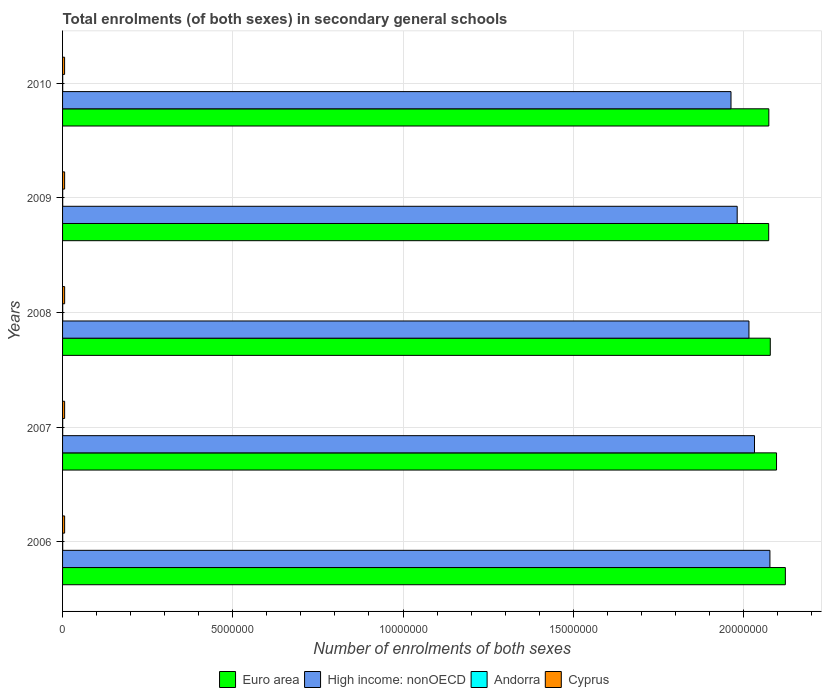How many different coloured bars are there?
Offer a terse response. 4. How many bars are there on the 3rd tick from the top?
Your answer should be compact. 4. What is the label of the 3rd group of bars from the top?
Keep it short and to the point. 2008. In how many cases, is the number of bars for a given year not equal to the number of legend labels?
Give a very brief answer. 0. What is the number of enrolments in secondary schools in Andorra in 2008?
Your answer should be compact. 3589. Across all years, what is the maximum number of enrolments in secondary schools in Andorra?
Your answer should be compact. 3692. Across all years, what is the minimum number of enrolments in secondary schools in Andorra?
Give a very brief answer. 3574. In which year was the number of enrolments in secondary schools in Euro area maximum?
Make the answer very short. 2006. What is the total number of enrolments in secondary schools in Euro area in the graph?
Ensure brevity in your answer.  1.04e+08. What is the difference between the number of enrolments in secondary schools in Euro area in 2006 and that in 2010?
Give a very brief answer. 4.85e+05. What is the difference between the number of enrolments in secondary schools in Andorra in 2008 and the number of enrolments in secondary schools in High income: nonOECD in 2007?
Keep it short and to the point. -2.03e+07. What is the average number of enrolments in secondary schools in Andorra per year?
Make the answer very short. 3610.8. In the year 2008, what is the difference between the number of enrolments in secondary schools in Euro area and number of enrolments in secondary schools in Cyprus?
Give a very brief answer. 2.07e+07. What is the ratio of the number of enrolments in secondary schools in Cyprus in 2006 to that in 2009?
Your answer should be compact. 1. Is the number of enrolments in secondary schools in Andorra in 2006 less than that in 2007?
Provide a short and direct response. No. What is the difference between the highest and the lowest number of enrolments in secondary schools in Andorra?
Offer a very short reply. 118. In how many years, is the number of enrolments in secondary schools in Andorra greater than the average number of enrolments in secondary schools in Andorra taken over all years?
Provide a succinct answer. 1. What does the 4th bar from the bottom in 2010 represents?
Your answer should be very brief. Cyprus. How many bars are there?
Give a very brief answer. 20. Are all the bars in the graph horizontal?
Provide a succinct answer. Yes. Are the values on the major ticks of X-axis written in scientific E-notation?
Give a very brief answer. No. Where does the legend appear in the graph?
Keep it short and to the point. Bottom center. What is the title of the graph?
Keep it short and to the point. Total enrolments (of both sexes) in secondary general schools. What is the label or title of the X-axis?
Keep it short and to the point. Number of enrolments of both sexes. What is the Number of enrolments of both sexes of Euro area in 2006?
Your response must be concise. 2.12e+07. What is the Number of enrolments of both sexes in High income: nonOECD in 2006?
Ensure brevity in your answer.  2.08e+07. What is the Number of enrolments of both sexes in Andorra in 2006?
Offer a terse response. 3597. What is the Number of enrolments of both sexes of Cyprus in 2006?
Provide a short and direct response. 6.04e+04. What is the Number of enrolments of both sexes of Euro area in 2007?
Keep it short and to the point. 2.10e+07. What is the Number of enrolments of both sexes of High income: nonOECD in 2007?
Keep it short and to the point. 2.03e+07. What is the Number of enrolments of both sexes in Andorra in 2007?
Your response must be concise. 3574. What is the Number of enrolments of both sexes of Cyprus in 2007?
Your answer should be compact. 6.06e+04. What is the Number of enrolments of both sexes of Euro area in 2008?
Provide a short and direct response. 2.08e+07. What is the Number of enrolments of both sexes in High income: nonOECD in 2008?
Your response must be concise. 2.02e+07. What is the Number of enrolments of both sexes of Andorra in 2008?
Provide a short and direct response. 3589. What is the Number of enrolments of both sexes of Cyprus in 2008?
Offer a terse response. 6.09e+04. What is the Number of enrolments of both sexes in Euro area in 2009?
Make the answer very short. 2.07e+07. What is the Number of enrolments of both sexes in High income: nonOECD in 2009?
Offer a very short reply. 1.98e+07. What is the Number of enrolments of both sexes in Andorra in 2009?
Keep it short and to the point. 3602. What is the Number of enrolments of both sexes of Cyprus in 2009?
Your answer should be compact. 6.05e+04. What is the Number of enrolments of both sexes of Euro area in 2010?
Offer a very short reply. 2.07e+07. What is the Number of enrolments of both sexes in High income: nonOECD in 2010?
Ensure brevity in your answer.  1.96e+07. What is the Number of enrolments of both sexes in Andorra in 2010?
Provide a succinct answer. 3692. What is the Number of enrolments of both sexes in Cyprus in 2010?
Offer a very short reply. 5.94e+04. Across all years, what is the maximum Number of enrolments of both sexes of Euro area?
Provide a succinct answer. 2.12e+07. Across all years, what is the maximum Number of enrolments of both sexes of High income: nonOECD?
Give a very brief answer. 2.08e+07. Across all years, what is the maximum Number of enrolments of both sexes of Andorra?
Offer a very short reply. 3692. Across all years, what is the maximum Number of enrolments of both sexes in Cyprus?
Offer a terse response. 6.09e+04. Across all years, what is the minimum Number of enrolments of both sexes of Euro area?
Ensure brevity in your answer.  2.07e+07. Across all years, what is the minimum Number of enrolments of both sexes in High income: nonOECD?
Make the answer very short. 1.96e+07. Across all years, what is the minimum Number of enrolments of both sexes in Andorra?
Your answer should be compact. 3574. Across all years, what is the minimum Number of enrolments of both sexes of Cyprus?
Provide a short and direct response. 5.94e+04. What is the total Number of enrolments of both sexes in Euro area in the graph?
Your answer should be compact. 1.04e+08. What is the total Number of enrolments of both sexes of High income: nonOECD in the graph?
Provide a short and direct response. 1.01e+08. What is the total Number of enrolments of both sexes in Andorra in the graph?
Give a very brief answer. 1.81e+04. What is the total Number of enrolments of both sexes in Cyprus in the graph?
Ensure brevity in your answer.  3.02e+05. What is the difference between the Number of enrolments of both sexes of Euro area in 2006 and that in 2007?
Give a very brief answer. 2.59e+05. What is the difference between the Number of enrolments of both sexes in High income: nonOECD in 2006 and that in 2007?
Your answer should be compact. 4.53e+05. What is the difference between the Number of enrolments of both sexes in Andorra in 2006 and that in 2007?
Give a very brief answer. 23. What is the difference between the Number of enrolments of both sexes of Cyprus in 2006 and that in 2007?
Your answer should be compact. -239. What is the difference between the Number of enrolments of both sexes in Euro area in 2006 and that in 2008?
Offer a very short reply. 4.43e+05. What is the difference between the Number of enrolments of both sexes of High income: nonOECD in 2006 and that in 2008?
Your response must be concise. 6.16e+05. What is the difference between the Number of enrolments of both sexes in Andorra in 2006 and that in 2008?
Offer a terse response. 8. What is the difference between the Number of enrolments of both sexes in Cyprus in 2006 and that in 2008?
Your answer should be compact. -505. What is the difference between the Number of enrolments of both sexes in Euro area in 2006 and that in 2009?
Ensure brevity in your answer.  4.89e+05. What is the difference between the Number of enrolments of both sexes of High income: nonOECD in 2006 and that in 2009?
Offer a terse response. 9.61e+05. What is the difference between the Number of enrolments of both sexes of Andorra in 2006 and that in 2009?
Your response must be concise. -5. What is the difference between the Number of enrolments of both sexes in Cyprus in 2006 and that in 2009?
Keep it short and to the point. -41. What is the difference between the Number of enrolments of both sexes of Euro area in 2006 and that in 2010?
Offer a very short reply. 4.85e+05. What is the difference between the Number of enrolments of both sexes in High income: nonOECD in 2006 and that in 2010?
Give a very brief answer. 1.14e+06. What is the difference between the Number of enrolments of both sexes in Andorra in 2006 and that in 2010?
Your response must be concise. -95. What is the difference between the Number of enrolments of both sexes of Cyprus in 2006 and that in 2010?
Provide a short and direct response. 984. What is the difference between the Number of enrolments of both sexes in Euro area in 2007 and that in 2008?
Make the answer very short. 1.84e+05. What is the difference between the Number of enrolments of both sexes of High income: nonOECD in 2007 and that in 2008?
Keep it short and to the point. 1.63e+05. What is the difference between the Number of enrolments of both sexes in Cyprus in 2007 and that in 2008?
Keep it short and to the point. -266. What is the difference between the Number of enrolments of both sexes of Euro area in 2007 and that in 2009?
Offer a terse response. 2.30e+05. What is the difference between the Number of enrolments of both sexes in High income: nonOECD in 2007 and that in 2009?
Make the answer very short. 5.08e+05. What is the difference between the Number of enrolments of both sexes in Cyprus in 2007 and that in 2009?
Provide a succinct answer. 198. What is the difference between the Number of enrolments of both sexes in Euro area in 2007 and that in 2010?
Your response must be concise. 2.26e+05. What is the difference between the Number of enrolments of both sexes in High income: nonOECD in 2007 and that in 2010?
Offer a terse response. 6.90e+05. What is the difference between the Number of enrolments of both sexes in Andorra in 2007 and that in 2010?
Your response must be concise. -118. What is the difference between the Number of enrolments of both sexes of Cyprus in 2007 and that in 2010?
Your answer should be compact. 1223. What is the difference between the Number of enrolments of both sexes of Euro area in 2008 and that in 2009?
Offer a very short reply. 4.64e+04. What is the difference between the Number of enrolments of both sexes of High income: nonOECD in 2008 and that in 2009?
Your answer should be compact. 3.46e+05. What is the difference between the Number of enrolments of both sexes of Cyprus in 2008 and that in 2009?
Your answer should be compact. 464. What is the difference between the Number of enrolments of both sexes in Euro area in 2008 and that in 2010?
Offer a terse response. 4.25e+04. What is the difference between the Number of enrolments of both sexes of High income: nonOECD in 2008 and that in 2010?
Your answer should be compact. 5.27e+05. What is the difference between the Number of enrolments of both sexes in Andorra in 2008 and that in 2010?
Offer a very short reply. -103. What is the difference between the Number of enrolments of both sexes in Cyprus in 2008 and that in 2010?
Give a very brief answer. 1489. What is the difference between the Number of enrolments of both sexes in Euro area in 2009 and that in 2010?
Offer a terse response. -3894. What is the difference between the Number of enrolments of both sexes of High income: nonOECD in 2009 and that in 2010?
Make the answer very short. 1.82e+05. What is the difference between the Number of enrolments of both sexes in Andorra in 2009 and that in 2010?
Make the answer very short. -90. What is the difference between the Number of enrolments of both sexes of Cyprus in 2009 and that in 2010?
Keep it short and to the point. 1025. What is the difference between the Number of enrolments of both sexes of Euro area in 2006 and the Number of enrolments of both sexes of High income: nonOECD in 2007?
Ensure brevity in your answer.  9.06e+05. What is the difference between the Number of enrolments of both sexes of Euro area in 2006 and the Number of enrolments of both sexes of Andorra in 2007?
Provide a succinct answer. 2.12e+07. What is the difference between the Number of enrolments of both sexes of Euro area in 2006 and the Number of enrolments of both sexes of Cyprus in 2007?
Give a very brief answer. 2.12e+07. What is the difference between the Number of enrolments of both sexes in High income: nonOECD in 2006 and the Number of enrolments of both sexes in Andorra in 2007?
Your answer should be compact. 2.08e+07. What is the difference between the Number of enrolments of both sexes of High income: nonOECD in 2006 and the Number of enrolments of both sexes of Cyprus in 2007?
Offer a terse response. 2.07e+07. What is the difference between the Number of enrolments of both sexes of Andorra in 2006 and the Number of enrolments of both sexes of Cyprus in 2007?
Your answer should be compact. -5.71e+04. What is the difference between the Number of enrolments of both sexes in Euro area in 2006 and the Number of enrolments of both sexes in High income: nonOECD in 2008?
Give a very brief answer. 1.07e+06. What is the difference between the Number of enrolments of both sexes of Euro area in 2006 and the Number of enrolments of both sexes of Andorra in 2008?
Keep it short and to the point. 2.12e+07. What is the difference between the Number of enrolments of both sexes of Euro area in 2006 and the Number of enrolments of both sexes of Cyprus in 2008?
Ensure brevity in your answer.  2.12e+07. What is the difference between the Number of enrolments of both sexes of High income: nonOECD in 2006 and the Number of enrolments of both sexes of Andorra in 2008?
Your answer should be compact. 2.08e+07. What is the difference between the Number of enrolments of both sexes in High income: nonOECD in 2006 and the Number of enrolments of both sexes in Cyprus in 2008?
Offer a very short reply. 2.07e+07. What is the difference between the Number of enrolments of both sexes of Andorra in 2006 and the Number of enrolments of both sexes of Cyprus in 2008?
Give a very brief answer. -5.73e+04. What is the difference between the Number of enrolments of both sexes of Euro area in 2006 and the Number of enrolments of both sexes of High income: nonOECD in 2009?
Offer a very short reply. 1.41e+06. What is the difference between the Number of enrolments of both sexes in Euro area in 2006 and the Number of enrolments of both sexes in Andorra in 2009?
Provide a succinct answer. 2.12e+07. What is the difference between the Number of enrolments of both sexes in Euro area in 2006 and the Number of enrolments of both sexes in Cyprus in 2009?
Make the answer very short. 2.12e+07. What is the difference between the Number of enrolments of both sexes of High income: nonOECD in 2006 and the Number of enrolments of both sexes of Andorra in 2009?
Make the answer very short. 2.08e+07. What is the difference between the Number of enrolments of both sexes of High income: nonOECD in 2006 and the Number of enrolments of both sexes of Cyprus in 2009?
Offer a very short reply. 2.07e+07. What is the difference between the Number of enrolments of both sexes of Andorra in 2006 and the Number of enrolments of both sexes of Cyprus in 2009?
Your answer should be very brief. -5.69e+04. What is the difference between the Number of enrolments of both sexes in Euro area in 2006 and the Number of enrolments of both sexes in High income: nonOECD in 2010?
Make the answer very short. 1.60e+06. What is the difference between the Number of enrolments of both sexes of Euro area in 2006 and the Number of enrolments of both sexes of Andorra in 2010?
Make the answer very short. 2.12e+07. What is the difference between the Number of enrolments of both sexes of Euro area in 2006 and the Number of enrolments of both sexes of Cyprus in 2010?
Give a very brief answer. 2.12e+07. What is the difference between the Number of enrolments of both sexes of High income: nonOECD in 2006 and the Number of enrolments of both sexes of Andorra in 2010?
Keep it short and to the point. 2.08e+07. What is the difference between the Number of enrolments of both sexes in High income: nonOECD in 2006 and the Number of enrolments of both sexes in Cyprus in 2010?
Offer a very short reply. 2.07e+07. What is the difference between the Number of enrolments of both sexes in Andorra in 2006 and the Number of enrolments of both sexes in Cyprus in 2010?
Offer a very short reply. -5.58e+04. What is the difference between the Number of enrolments of both sexes in Euro area in 2007 and the Number of enrolments of both sexes in High income: nonOECD in 2008?
Provide a succinct answer. 8.10e+05. What is the difference between the Number of enrolments of both sexes in Euro area in 2007 and the Number of enrolments of both sexes in Andorra in 2008?
Keep it short and to the point. 2.10e+07. What is the difference between the Number of enrolments of both sexes in Euro area in 2007 and the Number of enrolments of both sexes in Cyprus in 2008?
Provide a succinct answer. 2.09e+07. What is the difference between the Number of enrolments of both sexes of High income: nonOECD in 2007 and the Number of enrolments of both sexes of Andorra in 2008?
Give a very brief answer. 2.03e+07. What is the difference between the Number of enrolments of both sexes of High income: nonOECD in 2007 and the Number of enrolments of both sexes of Cyprus in 2008?
Provide a short and direct response. 2.03e+07. What is the difference between the Number of enrolments of both sexes of Andorra in 2007 and the Number of enrolments of both sexes of Cyprus in 2008?
Offer a terse response. -5.73e+04. What is the difference between the Number of enrolments of both sexes in Euro area in 2007 and the Number of enrolments of both sexes in High income: nonOECD in 2009?
Ensure brevity in your answer.  1.16e+06. What is the difference between the Number of enrolments of both sexes of Euro area in 2007 and the Number of enrolments of both sexes of Andorra in 2009?
Provide a short and direct response. 2.10e+07. What is the difference between the Number of enrolments of both sexes in Euro area in 2007 and the Number of enrolments of both sexes in Cyprus in 2009?
Provide a succinct answer. 2.09e+07. What is the difference between the Number of enrolments of both sexes of High income: nonOECD in 2007 and the Number of enrolments of both sexes of Andorra in 2009?
Your answer should be very brief. 2.03e+07. What is the difference between the Number of enrolments of both sexes of High income: nonOECD in 2007 and the Number of enrolments of both sexes of Cyprus in 2009?
Provide a succinct answer. 2.03e+07. What is the difference between the Number of enrolments of both sexes of Andorra in 2007 and the Number of enrolments of both sexes of Cyprus in 2009?
Provide a short and direct response. -5.69e+04. What is the difference between the Number of enrolments of both sexes of Euro area in 2007 and the Number of enrolments of both sexes of High income: nonOECD in 2010?
Your answer should be very brief. 1.34e+06. What is the difference between the Number of enrolments of both sexes of Euro area in 2007 and the Number of enrolments of both sexes of Andorra in 2010?
Your response must be concise. 2.10e+07. What is the difference between the Number of enrolments of both sexes of Euro area in 2007 and the Number of enrolments of both sexes of Cyprus in 2010?
Your answer should be very brief. 2.09e+07. What is the difference between the Number of enrolments of both sexes in High income: nonOECD in 2007 and the Number of enrolments of both sexes in Andorra in 2010?
Provide a short and direct response. 2.03e+07. What is the difference between the Number of enrolments of both sexes of High income: nonOECD in 2007 and the Number of enrolments of both sexes of Cyprus in 2010?
Give a very brief answer. 2.03e+07. What is the difference between the Number of enrolments of both sexes in Andorra in 2007 and the Number of enrolments of both sexes in Cyprus in 2010?
Your answer should be very brief. -5.59e+04. What is the difference between the Number of enrolments of both sexes of Euro area in 2008 and the Number of enrolments of both sexes of High income: nonOECD in 2009?
Provide a succinct answer. 9.72e+05. What is the difference between the Number of enrolments of both sexes in Euro area in 2008 and the Number of enrolments of both sexes in Andorra in 2009?
Give a very brief answer. 2.08e+07. What is the difference between the Number of enrolments of both sexes of Euro area in 2008 and the Number of enrolments of both sexes of Cyprus in 2009?
Give a very brief answer. 2.07e+07. What is the difference between the Number of enrolments of both sexes in High income: nonOECD in 2008 and the Number of enrolments of both sexes in Andorra in 2009?
Keep it short and to the point. 2.02e+07. What is the difference between the Number of enrolments of both sexes in High income: nonOECD in 2008 and the Number of enrolments of both sexes in Cyprus in 2009?
Provide a succinct answer. 2.01e+07. What is the difference between the Number of enrolments of both sexes of Andorra in 2008 and the Number of enrolments of both sexes of Cyprus in 2009?
Your answer should be very brief. -5.69e+04. What is the difference between the Number of enrolments of both sexes in Euro area in 2008 and the Number of enrolments of both sexes in High income: nonOECD in 2010?
Make the answer very short. 1.15e+06. What is the difference between the Number of enrolments of both sexes in Euro area in 2008 and the Number of enrolments of both sexes in Andorra in 2010?
Offer a terse response. 2.08e+07. What is the difference between the Number of enrolments of both sexes in Euro area in 2008 and the Number of enrolments of both sexes in Cyprus in 2010?
Offer a very short reply. 2.07e+07. What is the difference between the Number of enrolments of both sexes in High income: nonOECD in 2008 and the Number of enrolments of both sexes in Andorra in 2010?
Keep it short and to the point. 2.02e+07. What is the difference between the Number of enrolments of both sexes in High income: nonOECD in 2008 and the Number of enrolments of both sexes in Cyprus in 2010?
Offer a very short reply. 2.01e+07. What is the difference between the Number of enrolments of both sexes in Andorra in 2008 and the Number of enrolments of both sexes in Cyprus in 2010?
Provide a short and direct response. -5.58e+04. What is the difference between the Number of enrolments of both sexes of Euro area in 2009 and the Number of enrolments of both sexes of High income: nonOECD in 2010?
Offer a terse response. 1.11e+06. What is the difference between the Number of enrolments of both sexes in Euro area in 2009 and the Number of enrolments of both sexes in Andorra in 2010?
Offer a very short reply. 2.07e+07. What is the difference between the Number of enrolments of both sexes in Euro area in 2009 and the Number of enrolments of both sexes in Cyprus in 2010?
Offer a very short reply. 2.07e+07. What is the difference between the Number of enrolments of both sexes in High income: nonOECD in 2009 and the Number of enrolments of both sexes in Andorra in 2010?
Ensure brevity in your answer.  1.98e+07. What is the difference between the Number of enrolments of both sexes in High income: nonOECD in 2009 and the Number of enrolments of both sexes in Cyprus in 2010?
Your response must be concise. 1.98e+07. What is the difference between the Number of enrolments of both sexes in Andorra in 2009 and the Number of enrolments of both sexes in Cyprus in 2010?
Your answer should be very brief. -5.58e+04. What is the average Number of enrolments of both sexes in Euro area per year?
Make the answer very short. 2.09e+07. What is the average Number of enrolments of both sexes of High income: nonOECD per year?
Provide a succinct answer. 2.01e+07. What is the average Number of enrolments of both sexes in Andorra per year?
Your answer should be compact. 3610.8. What is the average Number of enrolments of both sexes in Cyprus per year?
Your response must be concise. 6.04e+04. In the year 2006, what is the difference between the Number of enrolments of both sexes in Euro area and Number of enrolments of both sexes in High income: nonOECD?
Offer a very short reply. 4.53e+05. In the year 2006, what is the difference between the Number of enrolments of both sexes in Euro area and Number of enrolments of both sexes in Andorra?
Provide a short and direct response. 2.12e+07. In the year 2006, what is the difference between the Number of enrolments of both sexes in Euro area and Number of enrolments of both sexes in Cyprus?
Your answer should be very brief. 2.12e+07. In the year 2006, what is the difference between the Number of enrolments of both sexes in High income: nonOECD and Number of enrolments of both sexes in Andorra?
Provide a short and direct response. 2.08e+07. In the year 2006, what is the difference between the Number of enrolments of both sexes of High income: nonOECD and Number of enrolments of both sexes of Cyprus?
Provide a succinct answer. 2.07e+07. In the year 2006, what is the difference between the Number of enrolments of both sexes in Andorra and Number of enrolments of both sexes in Cyprus?
Your answer should be compact. -5.68e+04. In the year 2007, what is the difference between the Number of enrolments of both sexes in Euro area and Number of enrolments of both sexes in High income: nonOECD?
Your answer should be compact. 6.47e+05. In the year 2007, what is the difference between the Number of enrolments of both sexes in Euro area and Number of enrolments of both sexes in Andorra?
Make the answer very short. 2.10e+07. In the year 2007, what is the difference between the Number of enrolments of both sexes in Euro area and Number of enrolments of both sexes in Cyprus?
Make the answer very short. 2.09e+07. In the year 2007, what is the difference between the Number of enrolments of both sexes of High income: nonOECD and Number of enrolments of both sexes of Andorra?
Give a very brief answer. 2.03e+07. In the year 2007, what is the difference between the Number of enrolments of both sexes in High income: nonOECD and Number of enrolments of both sexes in Cyprus?
Keep it short and to the point. 2.03e+07. In the year 2007, what is the difference between the Number of enrolments of both sexes in Andorra and Number of enrolments of both sexes in Cyprus?
Your response must be concise. -5.71e+04. In the year 2008, what is the difference between the Number of enrolments of both sexes in Euro area and Number of enrolments of both sexes in High income: nonOECD?
Your answer should be very brief. 6.26e+05. In the year 2008, what is the difference between the Number of enrolments of both sexes of Euro area and Number of enrolments of both sexes of Andorra?
Your answer should be very brief. 2.08e+07. In the year 2008, what is the difference between the Number of enrolments of both sexes of Euro area and Number of enrolments of both sexes of Cyprus?
Keep it short and to the point. 2.07e+07. In the year 2008, what is the difference between the Number of enrolments of both sexes in High income: nonOECD and Number of enrolments of both sexes in Andorra?
Offer a very short reply. 2.02e+07. In the year 2008, what is the difference between the Number of enrolments of both sexes of High income: nonOECD and Number of enrolments of both sexes of Cyprus?
Offer a very short reply. 2.01e+07. In the year 2008, what is the difference between the Number of enrolments of both sexes in Andorra and Number of enrolments of both sexes in Cyprus?
Give a very brief answer. -5.73e+04. In the year 2009, what is the difference between the Number of enrolments of both sexes of Euro area and Number of enrolments of both sexes of High income: nonOECD?
Offer a very short reply. 9.25e+05. In the year 2009, what is the difference between the Number of enrolments of both sexes of Euro area and Number of enrolments of both sexes of Andorra?
Make the answer very short. 2.07e+07. In the year 2009, what is the difference between the Number of enrolments of both sexes in Euro area and Number of enrolments of both sexes in Cyprus?
Provide a short and direct response. 2.07e+07. In the year 2009, what is the difference between the Number of enrolments of both sexes of High income: nonOECD and Number of enrolments of both sexes of Andorra?
Give a very brief answer. 1.98e+07. In the year 2009, what is the difference between the Number of enrolments of both sexes of High income: nonOECD and Number of enrolments of both sexes of Cyprus?
Give a very brief answer. 1.98e+07. In the year 2009, what is the difference between the Number of enrolments of both sexes in Andorra and Number of enrolments of both sexes in Cyprus?
Offer a terse response. -5.68e+04. In the year 2010, what is the difference between the Number of enrolments of both sexes of Euro area and Number of enrolments of both sexes of High income: nonOECD?
Your answer should be compact. 1.11e+06. In the year 2010, what is the difference between the Number of enrolments of both sexes of Euro area and Number of enrolments of both sexes of Andorra?
Keep it short and to the point. 2.07e+07. In the year 2010, what is the difference between the Number of enrolments of both sexes of Euro area and Number of enrolments of both sexes of Cyprus?
Offer a very short reply. 2.07e+07. In the year 2010, what is the difference between the Number of enrolments of both sexes in High income: nonOECD and Number of enrolments of both sexes in Andorra?
Offer a very short reply. 1.96e+07. In the year 2010, what is the difference between the Number of enrolments of both sexes in High income: nonOECD and Number of enrolments of both sexes in Cyprus?
Your answer should be very brief. 1.96e+07. In the year 2010, what is the difference between the Number of enrolments of both sexes of Andorra and Number of enrolments of both sexes of Cyprus?
Offer a terse response. -5.57e+04. What is the ratio of the Number of enrolments of both sexes in Euro area in 2006 to that in 2007?
Provide a succinct answer. 1.01. What is the ratio of the Number of enrolments of both sexes of High income: nonOECD in 2006 to that in 2007?
Provide a short and direct response. 1.02. What is the ratio of the Number of enrolments of both sexes in Andorra in 2006 to that in 2007?
Ensure brevity in your answer.  1.01. What is the ratio of the Number of enrolments of both sexes in Cyprus in 2006 to that in 2007?
Give a very brief answer. 1. What is the ratio of the Number of enrolments of both sexes in Euro area in 2006 to that in 2008?
Ensure brevity in your answer.  1.02. What is the ratio of the Number of enrolments of both sexes in High income: nonOECD in 2006 to that in 2008?
Provide a short and direct response. 1.03. What is the ratio of the Number of enrolments of both sexes in Andorra in 2006 to that in 2008?
Provide a short and direct response. 1. What is the ratio of the Number of enrolments of both sexes in Euro area in 2006 to that in 2009?
Ensure brevity in your answer.  1.02. What is the ratio of the Number of enrolments of both sexes in High income: nonOECD in 2006 to that in 2009?
Offer a very short reply. 1.05. What is the ratio of the Number of enrolments of both sexes in Andorra in 2006 to that in 2009?
Keep it short and to the point. 1. What is the ratio of the Number of enrolments of both sexes of Euro area in 2006 to that in 2010?
Make the answer very short. 1.02. What is the ratio of the Number of enrolments of both sexes of High income: nonOECD in 2006 to that in 2010?
Make the answer very short. 1.06. What is the ratio of the Number of enrolments of both sexes of Andorra in 2006 to that in 2010?
Make the answer very short. 0.97. What is the ratio of the Number of enrolments of both sexes in Cyprus in 2006 to that in 2010?
Ensure brevity in your answer.  1.02. What is the ratio of the Number of enrolments of both sexes in Euro area in 2007 to that in 2008?
Make the answer very short. 1.01. What is the ratio of the Number of enrolments of both sexes of High income: nonOECD in 2007 to that in 2008?
Make the answer very short. 1.01. What is the ratio of the Number of enrolments of both sexes of Andorra in 2007 to that in 2008?
Your response must be concise. 1. What is the ratio of the Number of enrolments of both sexes in Cyprus in 2007 to that in 2008?
Provide a short and direct response. 1. What is the ratio of the Number of enrolments of both sexes in Euro area in 2007 to that in 2009?
Your answer should be compact. 1.01. What is the ratio of the Number of enrolments of both sexes in High income: nonOECD in 2007 to that in 2009?
Ensure brevity in your answer.  1.03. What is the ratio of the Number of enrolments of both sexes of Cyprus in 2007 to that in 2009?
Your answer should be very brief. 1. What is the ratio of the Number of enrolments of both sexes of Euro area in 2007 to that in 2010?
Ensure brevity in your answer.  1.01. What is the ratio of the Number of enrolments of both sexes of High income: nonOECD in 2007 to that in 2010?
Provide a short and direct response. 1.04. What is the ratio of the Number of enrolments of both sexes in Cyprus in 2007 to that in 2010?
Provide a short and direct response. 1.02. What is the ratio of the Number of enrolments of both sexes of Euro area in 2008 to that in 2009?
Keep it short and to the point. 1. What is the ratio of the Number of enrolments of both sexes in High income: nonOECD in 2008 to that in 2009?
Offer a very short reply. 1.02. What is the ratio of the Number of enrolments of both sexes in Andorra in 2008 to that in 2009?
Your answer should be very brief. 1. What is the ratio of the Number of enrolments of both sexes of Cyprus in 2008 to that in 2009?
Give a very brief answer. 1.01. What is the ratio of the Number of enrolments of both sexes of High income: nonOECD in 2008 to that in 2010?
Offer a terse response. 1.03. What is the ratio of the Number of enrolments of both sexes of Andorra in 2008 to that in 2010?
Provide a succinct answer. 0.97. What is the ratio of the Number of enrolments of both sexes in Cyprus in 2008 to that in 2010?
Offer a terse response. 1.03. What is the ratio of the Number of enrolments of both sexes in High income: nonOECD in 2009 to that in 2010?
Offer a very short reply. 1.01. What is the ratio of the Number of enrolments of both sexes of Andorra in 2009 to that in 2010?
Offer a terse response. 0.98. What is the ratio of the Number of enrolments of both sexes in Cyprus in 2009 to that in 2010?
Your response must be concise. 1.02. What is the difference between the highest and the second highest Number of enrolments of both sexes of Euro area?
Provide a succinct answer. 2.59e+05. What is the difference between the highest and the second highest Number of enrolments of both sexes of High income: nonOECD?
Your answer should be compact. 4.53e+05. What is the difference between the highest and the second highest Number of enrolments of both sexes of Andorra?
Ensure brevity in your answer.  90. What is the difference between the highest and the second highest Number of enrolments of both sexes in Cyprus?
Ensure brevity in your answer.  266. What is the difference between the highest and the lowest Number of enrolments of both sexes of Euro area?
Your response must be concise. 4.89e+05. What is the difference between the highest and the lowest Number of enrolments of both sexes in High income: nonOECD?
Your answer should be compact. 1.14e+06. What is the difference between the highest and the lowest Number of enrolments of both sexes of Andorra?
Your answer should be compact. 118. What is the difference between the highest and the lowest Number of enrolments of both sexes in Cyprus?
Your response must be concise. 1489. 